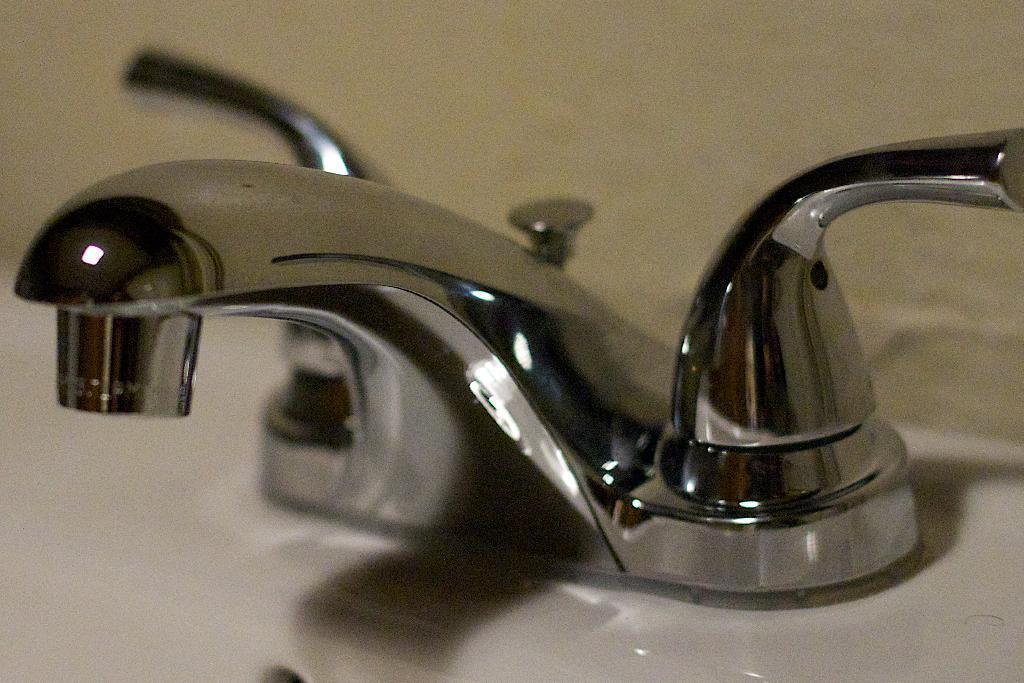Describe this image in one or two sentences. In this image there is a sink truncated towards the bottom of the image, there are taps, at the background of the image there is a wall truncated. 